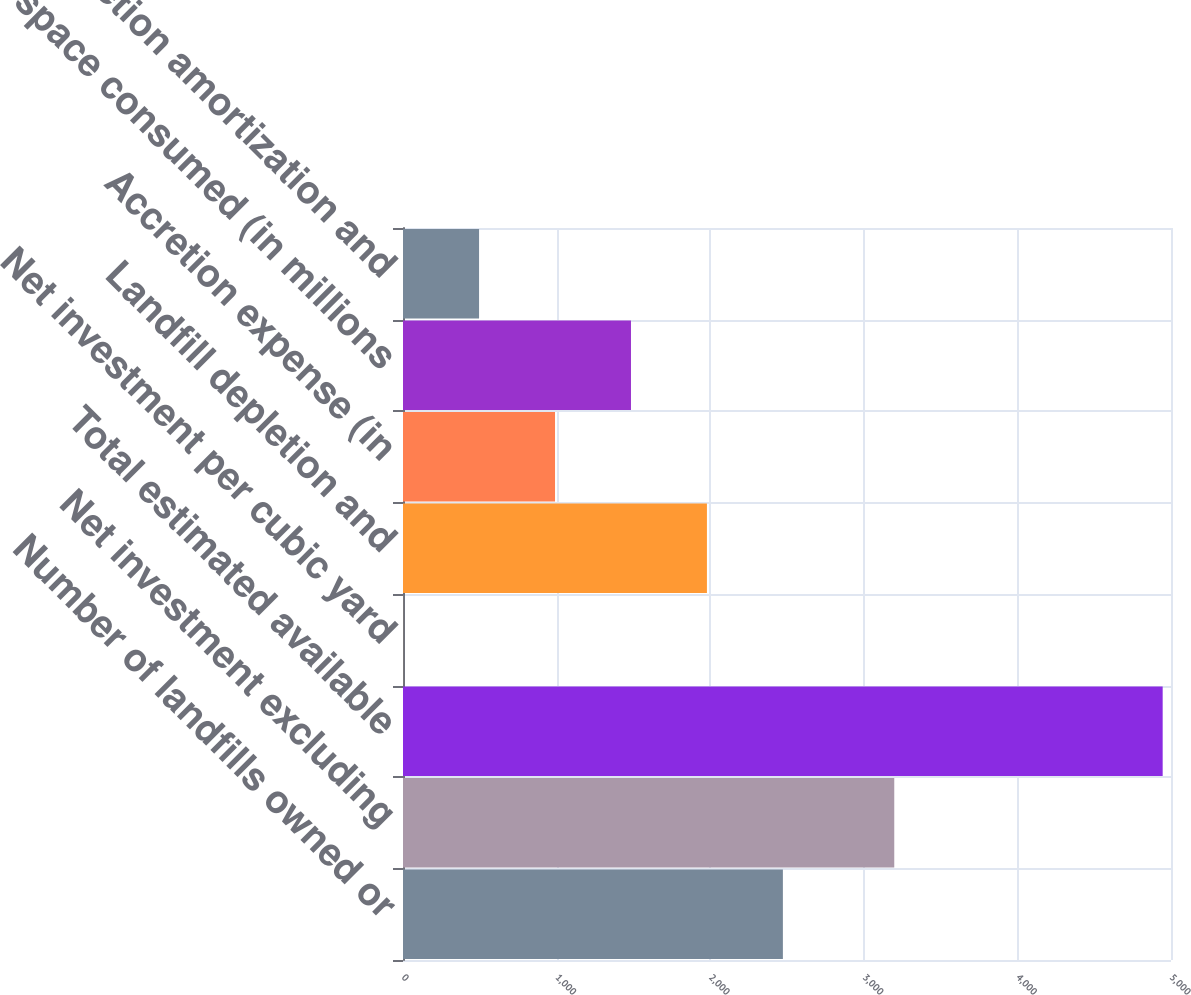Convert chart to OTSL. <chart><loc_0><loc_0><loc_500><loc_500><bar_chart><fcel>Number of landfills owned or<fcel>Net investment excluding<fcel>Total estimated available<fcel>Net investment per cubic yard<fcel>Landfill depletion and<fcel>Accretion expense (in<fcel>Airspace consumed (in millions<fcel>Depletion amortization and<nl><fcel>2473.24<fcel>3198.3<fcel>4945.8<fcel>0.65<fcel>1978.73<fcel>989.69<fcel>1484.21<fcel>495.17<nl></chart> 